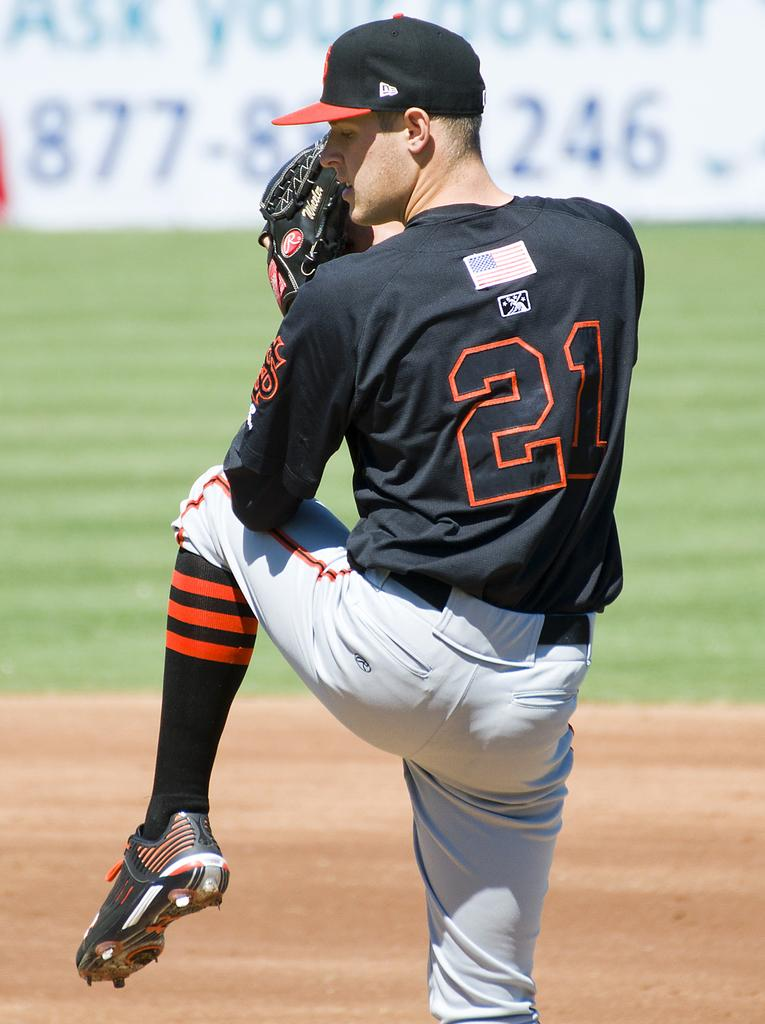Provide a one-sentence caption for the provided image. Number 21 is about to pitch the ball, with his leg in the air. 